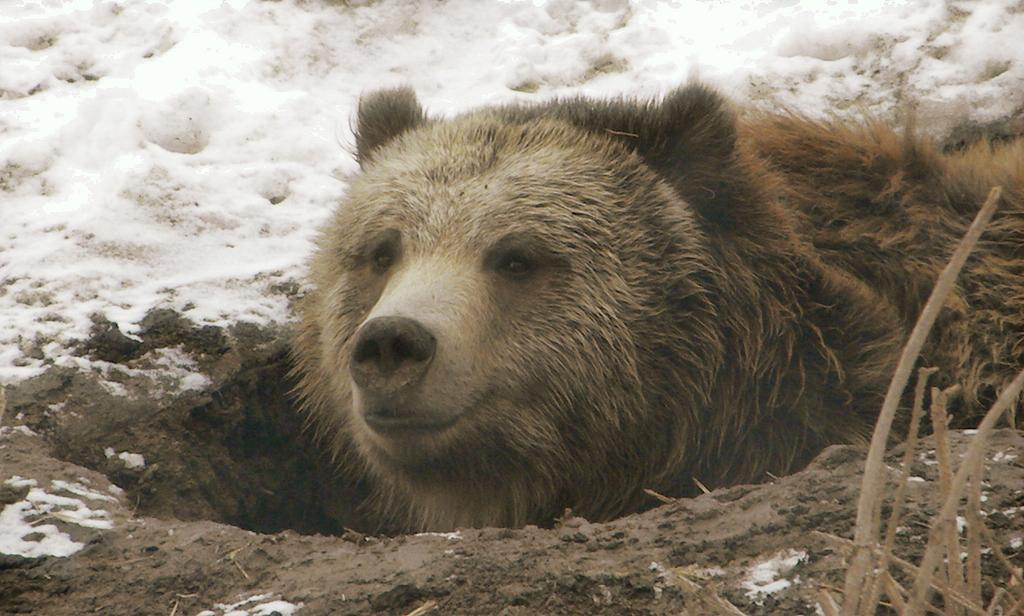What animal is in the image? There is a bear in the image. What color is the bear? The bear is brown in color. What type of surface is visible in the image? There is ground visible in the image. What is covering the ground in the image? Snow is present on the ground. What can be seen on the right side of the image? There are stems of plants on the right side of the image. How much credit does the bear have in the image? There is no mention of credit or any financial aspect in the image, as it features a brown bear in a snowy environment. 